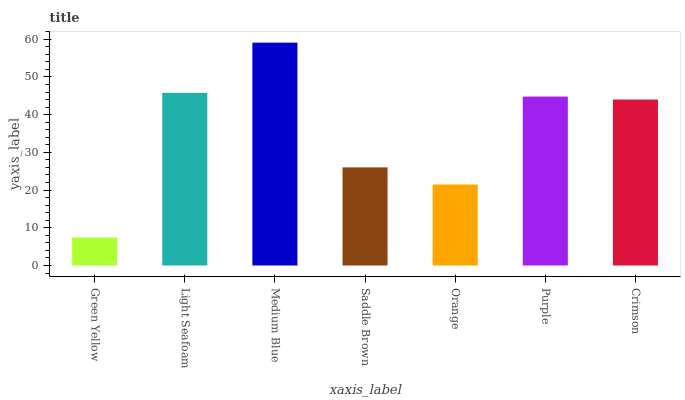Is Light Seafoam the minimum?
Answer yes or no. No. Is Light Seafoam the maximum?
Answer yes or no. No. Is Light Seafoam greater than Green Yellow?
Answer yes or no. Yes. Is Green Yellow less than Light Seafoam?
Answer yes or no. Yes. Is Green Yellow greater than Light Seafoam?
Answer yes or no. No. Is Light Seafoam less than Green Yellow?
Answer yes or no. No. Is Crimson the high median?
Answer yes or no. Yes. Is Crimson the low median?
Answer yes or no. Yes. Is Saddle Brown the high median?
Answer yes or no. No. Is Saddle Brown the low median?
Answer yes or no. No. 